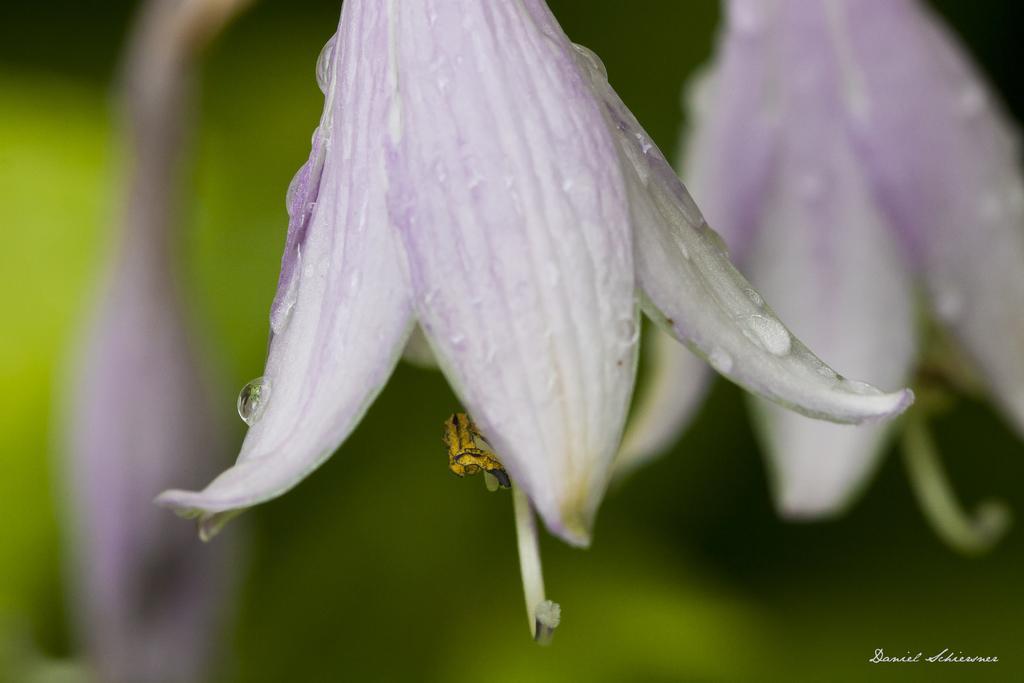Please provide a concise description of this image. As we can see in the image in the front there are flowers and the background is blurred. 